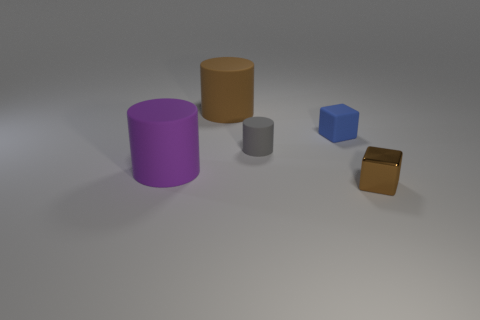Is there a large brown object that has the same shape as the tiny gray object?
Provide a short and direct response. Yes. Do the purple thing and the large object behind the purple rubber thing have the same material?
Provide a short and direct response. Yes. What color is the rubber block?
Keep it short and to the point. Blue. How many large rubber objects are behind the small thing to the right of the cube behind the tiny brown shiny thing?
Give a very brief answer. 2. There is a large purple object; are there any small brown metal cubes to the left of it?
Your answer should be compact. No. How many tiny blue cubes have the same material as the purple thing?
Offer a very short reply. 1. How many things are large cylinders or blue rubber objects?
Your answer should be very brief. 3. Are any big purple matte things visible?
Your answer should be compact. Yes. The big cylinder in front of the small cylinder in front of the small rubber object to the right of the small gray object is made of what material?
Your answer should be very brief. Rubber. Is the number of small cylinders in front of the tiny metal block less than the number of large matte cylinders?
Your answer should be compact. Yes. 